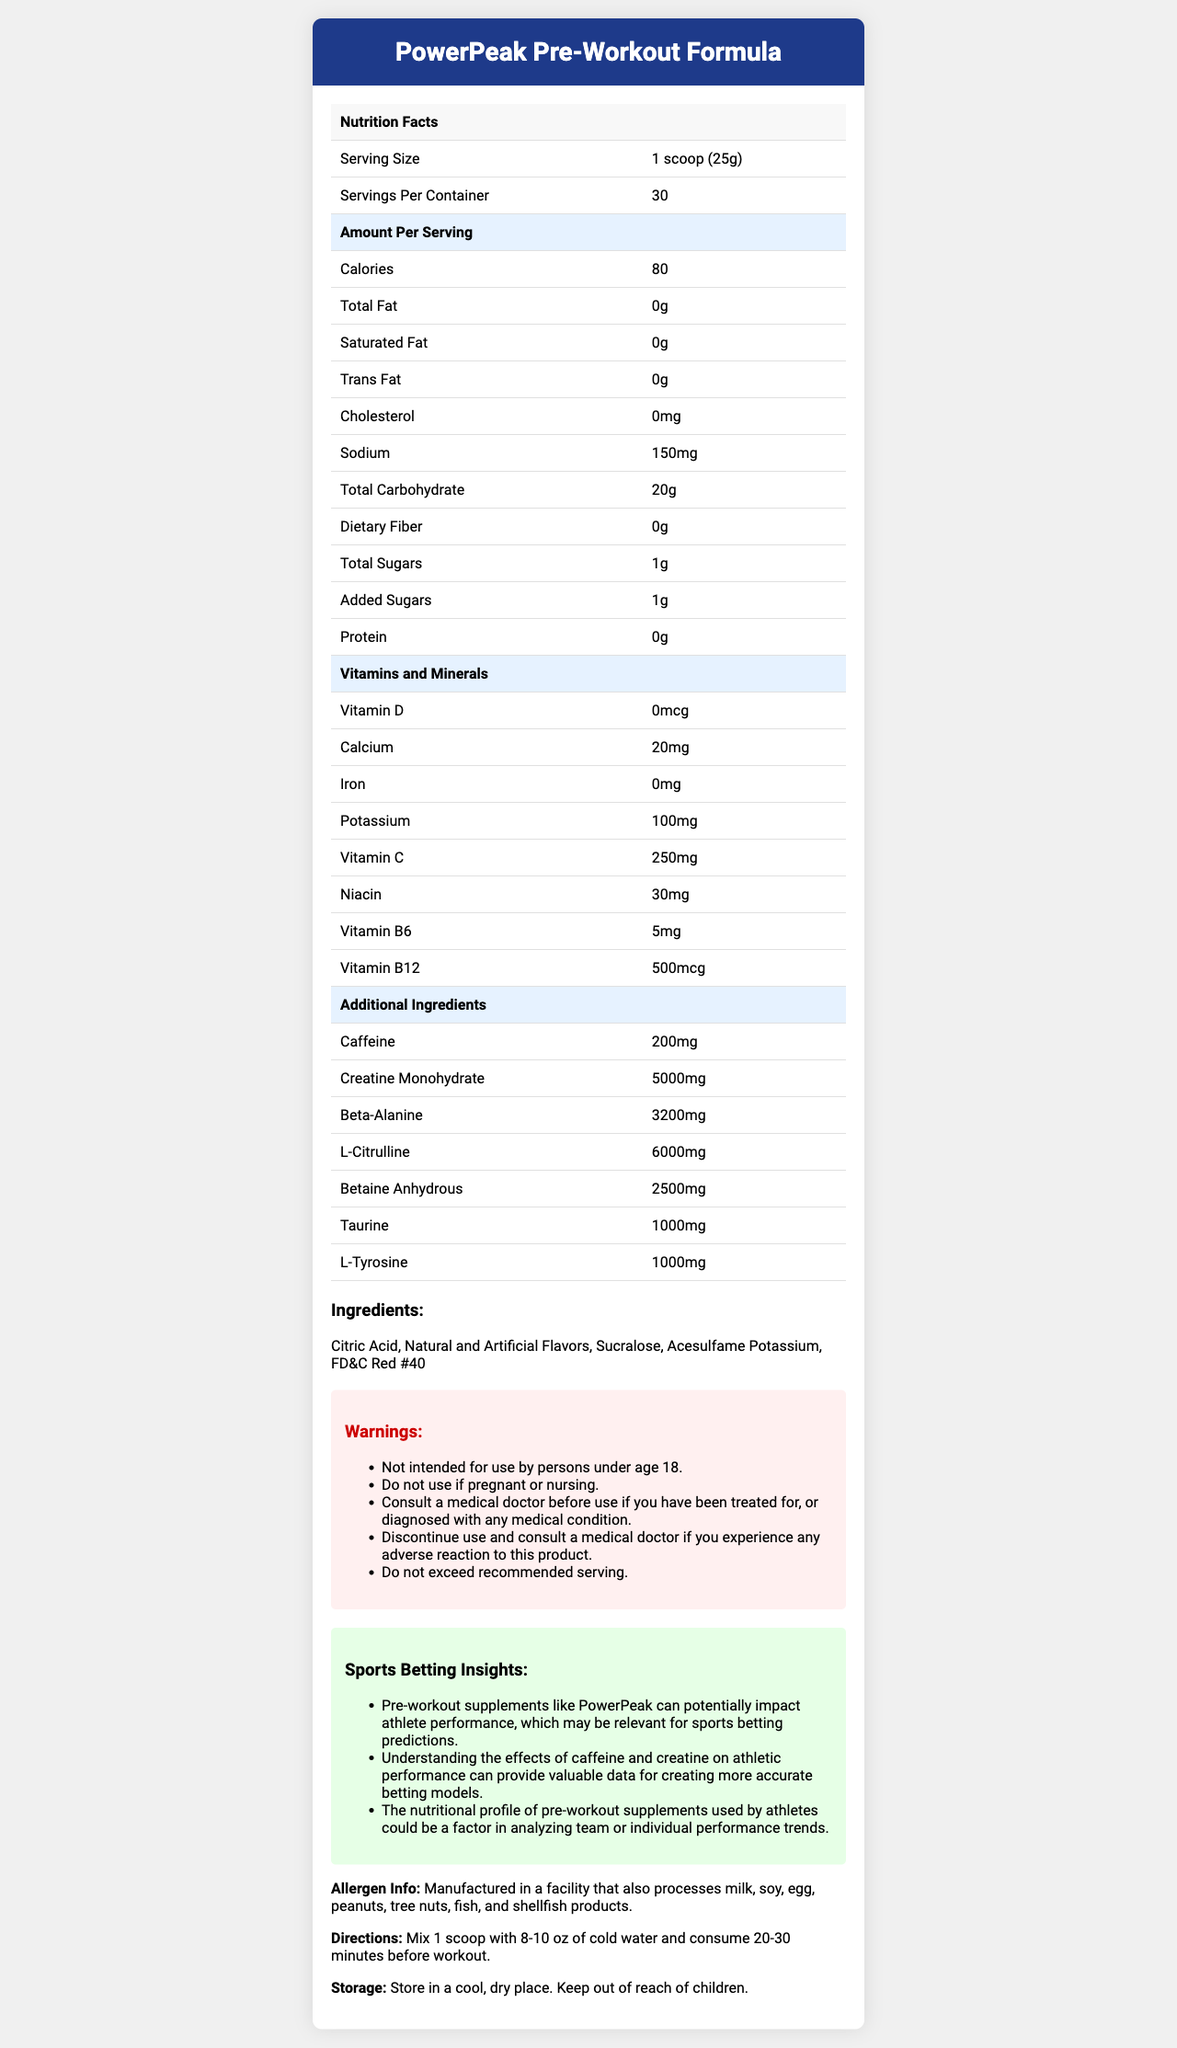what is the serving size of PowerPeak Pre-Workout Formula? The serving size is listed under the Nutrition Facts section as "1 scoop (25g)".
Answer: 1 scoop (25g) how many calories are in one serving of this product? The Nutrition Facts section lists the calories per serving as 80.
Answer: 80 which vitamin or mineral has the highest amount in the supplement? The highest amount of a vitamin or mineral listed is Vitamin B12 with 500 mcg per serving.
Answer: Vitamin B12 how much caffeine is in each serving? The amount of caffeine per serving is listed as 200 mg in the Additional Ingredients section.
Answer: 200 mg what is the recommended serving size to mix with water before a workout? The Directions section states to mix 1 scoop with 8-10 oz of cold water and consume 20-30 minutes before the workout.
Answer: 1 scoop is this product intended for children under 18? The Warnings section clearly states that it is not intended for use by persons under age 18.
Answer: No what allergens are processed in the manufacturing facility? The Allergen Info section mentions all of these allergens as being processed in the facility.
Answer: milk, soy, egg, peanuts, tree nuts, fish, shellfish what type of flavors are included in the ingredients? The Ingredients section lists "Natural and Artificial Flavors" among the ingredients.
Answer: Natural and Artificial Flavors how many servings does one container provide? The Servings Per Container section lists the number of servings as 30.
Answer: 30 which ingredient is present in the largest amount in mg? The Additional Ingredients section lists Creatine Monohydrate at 5000 mg per serving, which is the highest.
Answer: Creatine Monohydrate which of the following are not included in the warnings section? A. Consult a medical doctor before use B. Not intended for persons under age 18 C. Store out of reach of children D. Discontinue use if adverse reactions occur The Warnings section includes A, B, and D but storing out of reach of children pertains to the Storage section.
Answer: C what is the correct option for the amount of potassium per serving? 1. 20 mg 2. 100 mg 3. 250 mg 4. 500 mg The Nutrition Facts section lists the potassium amount per serving as 100 mg.
Answer: 2 is this pre-workout supplement considered high in vitamin C? The Nutrition Facts section indicates that it contains 250 mg of Vitamin C, which is a high amount.
Answer: Yes summarize the main idea of this document. The summary includes the product name, detailed nutrition facts, vitamin and mineral content, additional ingredients, allergen information, usage directions, warnings, and relevant sports betting insights.
Answer: The document provides detailed information on the nutrition, ingredients, serving size, and warnings of the PowerPeak Pre-Workout Formula, along with its potential implications for sports betting related to athletic performance. how much L-Citrulline is in each serving? The Additional Ingredients section lists L-Citrulline as present at 6000 mg per serving.
Answer: 6000 mg what is the storage recommendation? The Storage section provides this specific storage advice.
Answer: Store in a cool, dry place. Keep out of reach of children. what are the effects of creatine on sports performance? The document includes Creatine Monohydrate content but does not detail its specific effects on sports performance.
Answer: Not enough information 